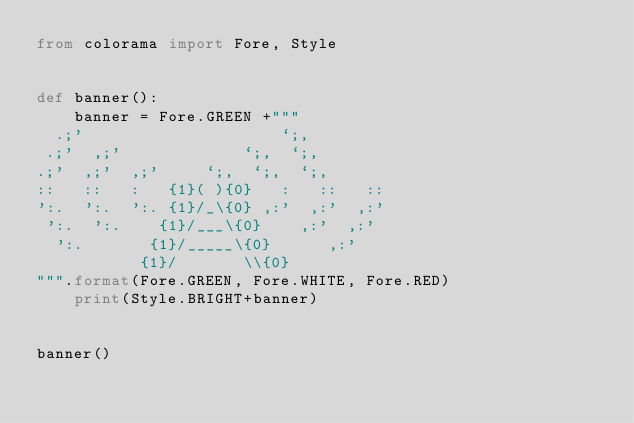<code> <loc_0><loc_0><loc_500><loc_500><_Python_>from colorama import Fore, Style


def banner():
    banner = Fore.GREEN +"""                                             
  .;'                     `;,
 .;'  ,;'             `;,  `;,  
.;'  ,;'  ,;'     `;,  `;,  `;,
::   ::   :   {1}( ){0}   :   ::   ::                              
':.  ':.  ':. {1}/_\{0} ,:'  ,:'  ,:'          
 ':.  ':.    {1}/___\{0}    ,:'  ,:' 
  ':.       {1}/_____\{0}      ,:'
           {1}/       \\{0}
""".format(Fore.GREEN, Fore.WHITE, Fore.RED)
    print(Style.BRIGHT+banner)


banner()
</code> 